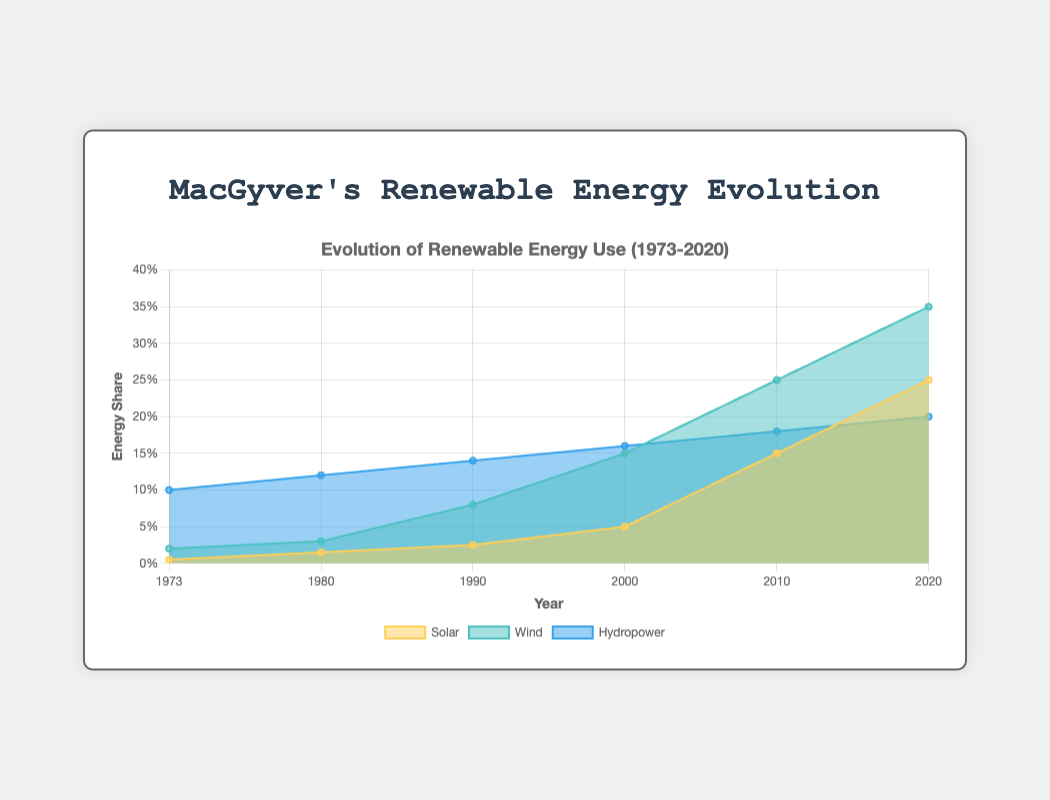What's the title of the chart? The title is displayed at the top of the chart. It reads "Evolution of Renewable Energy Use (1973-2020)."
Answer: Evolution of Renewable Energy Use (1973-2020) Which energy source had the highest share in 1973? Observing 1973, the chart shows Hydropower with the highest share among Solar, Wind, and Hydropower.
Answer: Hydropower How did Solar energy usage change from 1973 to 2020? We can see that Solar energy grew from 0.005 in 1973 to 0.25 in 2020 by looking at the dataset labeled 'Solar.'
Answer: Increased Which year marks the point where Wind energy usage surpasses Hydropower? Comparing the two lines, Wind energy usage exceeds Hydropower usage between 2010 and 2020, specifically in 2020.
Answer: 2020 What is the combined share of Solar and Wind energy in 2020? Combining the shares of Solar (0.25) and Wind (0.35) in 2020 gives us 0.25 + 0.35 = 0.60.
Answer: 0.60 What was the approximate value of Hydropower usage in 1980? Looking at the Hydropower data series at the year 1980, the value is around 0.12.
Answer: 0.12 Between which two consecutive years did Solar energy see the greatest increase? Calculating the differences between consecutive years for Solar: 
1980-1973: 0.015-0.005 = 0.01
1990-1980: 0.025-0.015 = 0.01
2000-1990: 0.05-0.025 = 0.025
2010-2000: 0.15-0.05 = 0.1
2020-2010: 0.25-0.15 = 0.1
The greatest increase occurred between 2000 and 2010, and 2010 and 2020, both with an increase of 0.1.
Answer: 2000-2010 and 2010-2020 In 1990, what was the difference in energy share between Hydropower and Wind? Comparing Hydropower (0.14) and Wind (0.08) in 1990, the difference is 0.14 - 0.08 = 0.06.
Answer: 0.06 What is the trend of Wind energy share from 1973 to 2020? The line representing Wind steadily increases from 0.02 in 1973 to 0.35 in 2020.
Answer: Increasing Which energy source showed the most consistent growth over the past 50 years? The datasets show that Hydropower consistently grows every decade, maintaining small incremental increases compared to the more rapid rises of Solar and Wind.
Answer: Hydropower 